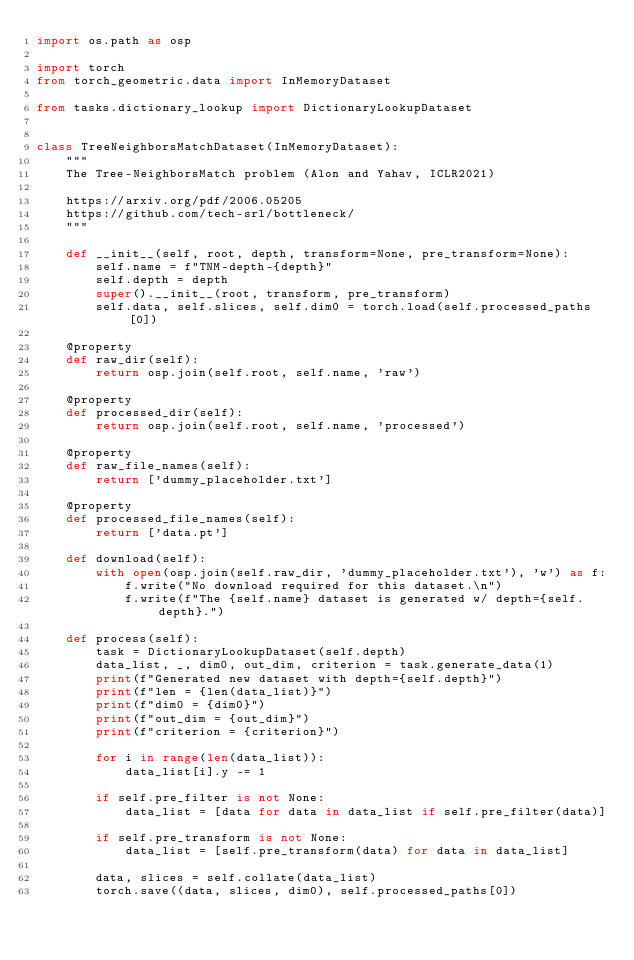Convert code to text. <code><loc_0><loc_0><loc_500><loc_500><_Python_>import os.path as osp

import torch
from torch_geometric.data import InMemoryDataset

from tasks.dictionary_lookup import DictionaryLookupDataset


class TreeNeighborsMatchDataset(InMemoryDataset):
    """
    The Tree-NeighborsMatch problem (Alon and Yahav, ICLR2021)

    https://arxiv.org/pdf/2006.05205
    https://github.com/tech-srl/bottleneck/
    """

    def __init__(self, root, depth, transform=None, pre_transform=None):
        self.name = f"TNM-depth-{depth}"
        self.depth = depth
        super().__init__(root, transform, pre_transform)
        self.data, self.slices, self.dim0 = torch.load(self.processed_paths[0])

    @property
    def raw_dir(self):
        return osp.join(self.root, self.name, 'raw')

    @property
    def processed_dir(self):
        return osp.join(self.root, self.name, 'processed')

    @property
    def raw_file_names(self):
        return ['dummy_placeholder.txt']

    @property
    def processed_file_names(self):
        return ['data.pt']

    def download(self):
        with open(osp.join(self.raw_dir, 'dummy_placeholder.txt'), 'w') as f:
            f.write("No download required for this dataset.\n")
            f.write(f"The {self.name} dataset is generated w/ depth={self.depth}.")

    def process(self):
        task = DictionaryLookupDataset(self.depth)
        data_list, _, dim0, out_dim, criterion = task.generate_data(1)
        print(f"Generated new dataset with depth={self.depth}")
        print(f"len = {len(data_list)}")
        print(f"dim0 = {dim0}")
        print(f"out_dim = {out_dim}")
        print(f"criterion = {criterion}")

        for i in range(len(data_list)):
            data_list[i].y -= 1

        if self.pre_filter is not None:
            data_list = [data for data in data_list if self.pre_filter(data)]

        if self.pre_transform is not None:
            data_list = [self.pre_transform(data) for data in data_list]

        data, slices = self.collate(data_list)
        torch.save((data, slices, dim0), self.processed_paths[0])
</code> 